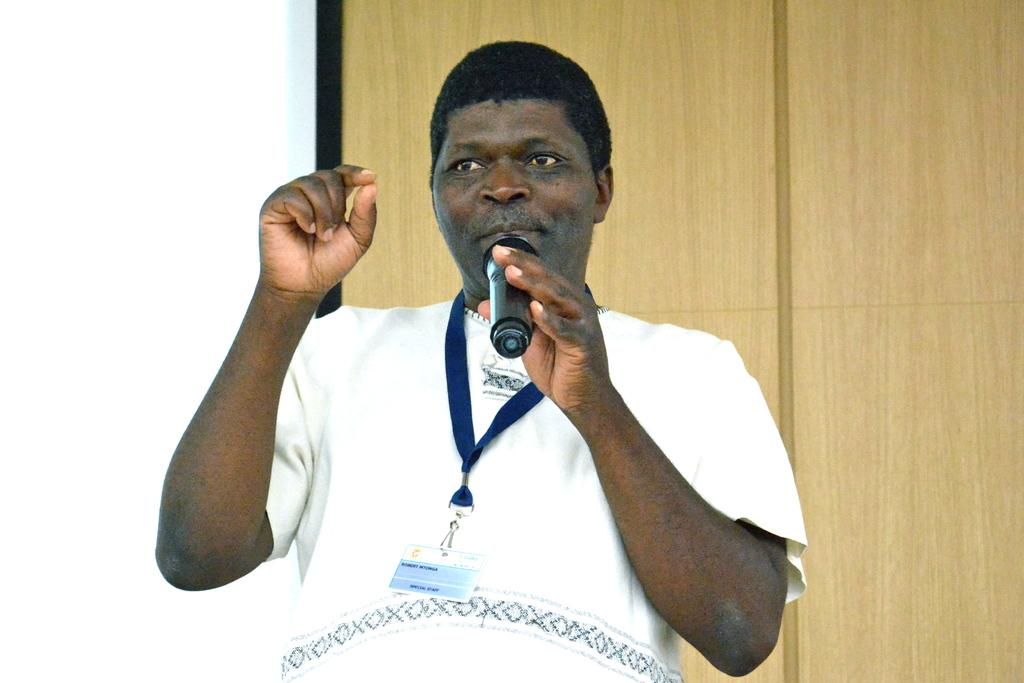What is the main subject of the image? There is a man in the middle of the image. What is the man wearing? The man is wearing a white t-shirt. What is the man holding in the image? The man is holding a microphone. What can be seen in the background of the image? There is a wall in the background of the image. How many cars are parked in front of the wall in the image? There are no cars present in the image; it only features a man holding a microphone in front of a wall. 